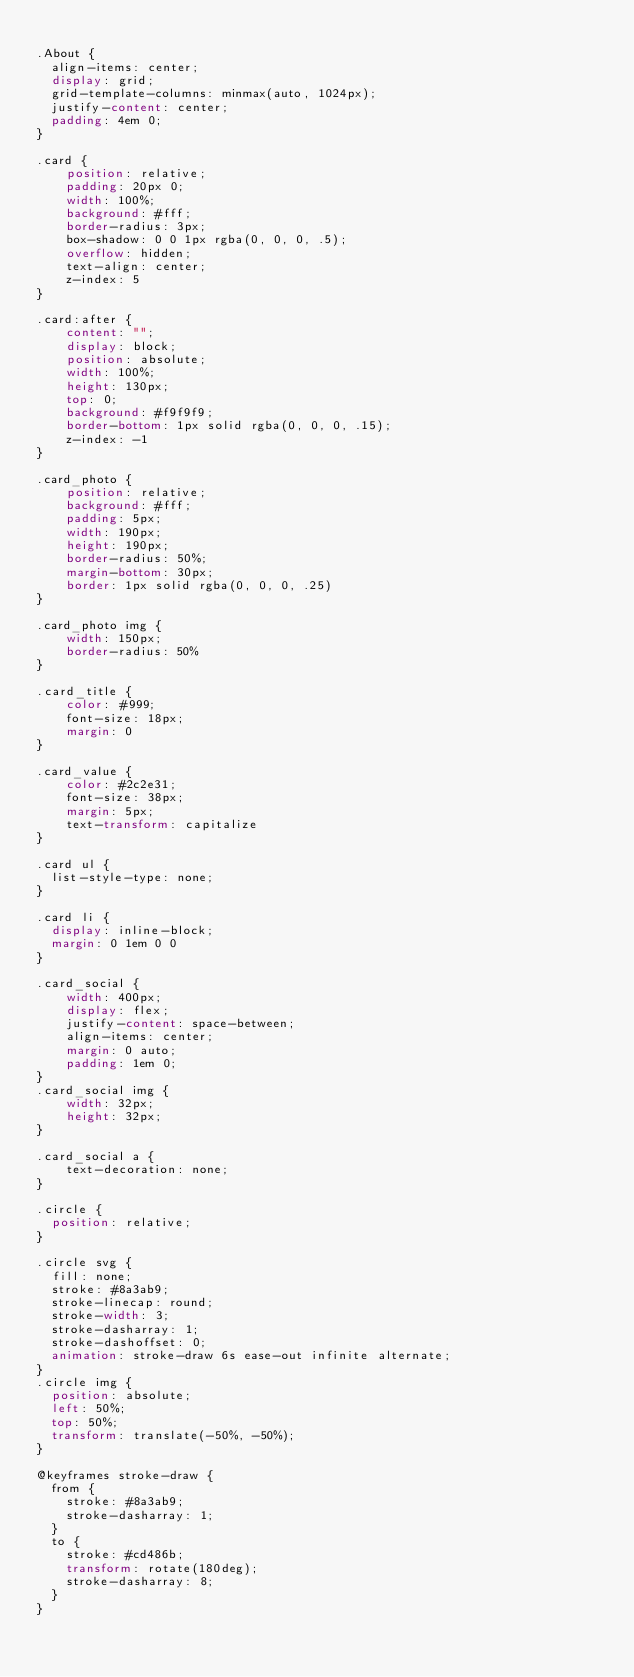<code> <loc_0><loc_0><loc_500><loc_500><_CSS_>
.About {
  align-items: center;
  display: grid;
  grid-template-columns: minmax(auto, 1024px);
  justify-content: center;
  padding: 4em 0;
}

.card {
	position: relative;
	padding: 20px 0;
	width: 100%;
	background: #fff;
	border-radius: 3px;
	box-shadow: 0 0 1px rgba(0, 0, 0, .5);
	overflow: hidden;
	text-align: center;
	z-index: 5
}

.card:after {
	content: "";
	display: block;
	position: absolute;
	width: 100%;
	height: 130px;
	top: 0;
	background: #f9f9f9;
	border-bottom: 1px solid rgba(0, 0, 0, .15);
	z-index: -1
}

.card_photo {
	position: relative;
	background: #fff;
	padding: 5px;
	width: 190px;
	height: 190px;
	border-radius: 50%;
	margin-bottom: 30px;
	border: 1px solid rgba(0, 0, 0, .25)
}

.card_photo img {
	width: 150px;
	border-radius: 50%
}

.card_title {
	color: #999;
	font-size: 18px;
	margin: 0
}

.card_value {
	color: #2c2e31;
	font-size: 38px;
	margin: 5px;
	text-transform: capitalize
}

.card ul {
  list-style-type: none;
}

.card li {
  display: inline-block;
  margin: 0 1em 0 0
}

.card_social {
	width: 400px;
	display: flex;
	justify-content: space-between;
	align-items: center;
	margin: 0 auto;
	padding: 1em 0;
}
.card_social img {
	width: 32px;
	height: 32px;
}

.card_social a {
	text-decoration: none;
}

.circle {
  position: relative;
}

.circle svg {
  fill: none;
  stroke: #8a3ab9;
  stroke-linecap: round;
  stroke-width: 3;
  stroke-dasharray: 1;
  stroke-dashoffset: 0;
  animation: stroke-draw 6s ease-out infinite alternate;
}
.circle img {
  position: absolute;
  left: 50%;
  top: 50%;
  transform: translate(-50%, -50%);
}

@keyframes stroke-draw {
  from {
    stroke: #8a3ab9;
    stroke-dasharray: 1;
  }
  to {
    stroke: #cd486b;
    transform: rotate(180deg);
    stroke-dasharray: 8;
  }
}</code> 